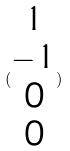<formula> <loc_0><loc_0><loc_500><loc_500>( \begin{matrix} 1 \\ - 1 \\ 0 \\ 0 \end{matrix} )</formula> 